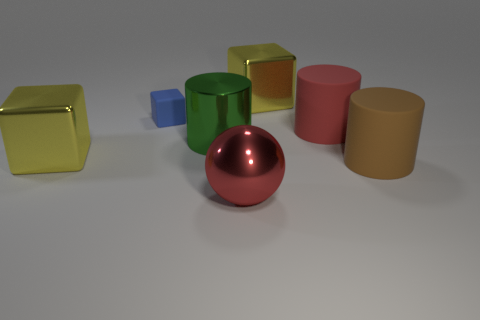The blue thing that is made of the same material as the large brown cylinder is what shape?
Ensure brevity in your answer.  Cube. Do the large cylinder that is behind the large shiny cylinder and the big yellow cube that is in front of the big green object have the same material?
Keep it short and to the point. No. What number of things are big cyan metal objects or large shiny cubes to the right of the large red metallic object?
Provide a short and direct response. 1. What shape is the thing that is the same color as the big sphere?
Ensure brevity in your answer.  Cylinder. What is the material of the blue thing?
Offer a terse response. Rubber. Is the big brown object made of the same material as the blue cube?
Keep it short and to the point. Yes. How many metallic things are large green cylinders or big blocks?
Keep it short and to the point. 3. There is a big yellow object that is right of the small blue block; what shape is it?
Make the answer very short. Cube. There is a red object that is made of the same material as the small blue block; what is its size?
Offer a very short reply. Large. What shape is the big thing that is on the right side of the large metallic sphere and in front of the red matte thing?
Provide a succinct answer. Cylinder. 